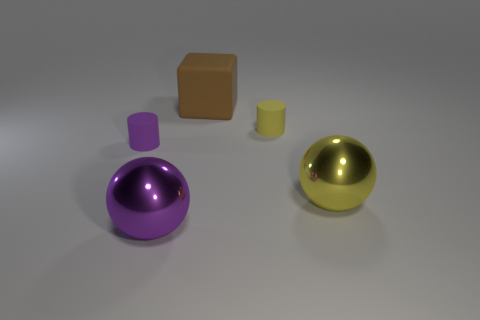Subtract 1 cylinders. How many cylinders are left? 1 Add 3 rubber cubes. How many objects exist? 8 Subtract all purple cylinders. How many cylinders are left? 1 Subtract 0 green cylinders. How many objects are left? 5 Subtract all blocks. How many objects are left? 4 Subtract all gray balls. Subtract all yellow blocks. How many balls are left? 2 Subtract all purple cylinders. How many cyan balls are left? 0 Subtract all small yellow matte spheres. Subtract all large metallic balls. How many objects are left? 3 Add 2 big purple objects. How many big purple objects are left? 3 Add 5 red shiny balls. How many red shiny balls exist? 5 